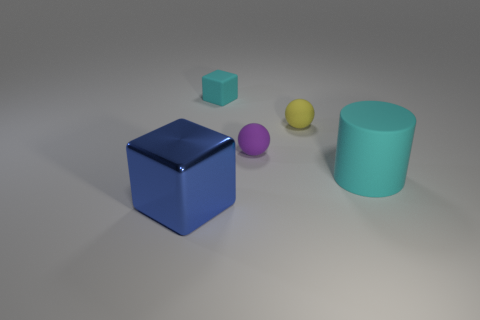How big is the cube that is to the right of the large cube?
Your answer should be very brief. Small. There is a cylinder that is the same size as the blue object; what is its color?
Provide a short and direct response. Cyan. Are there any small matte objects that have the same color as the big cylinder?
Offer a terse response. Yes. Are there fewer big metallic objects on the right side of the big matte object than purple things to the right of the cyan cube?
Give a very brief answer. Yes. What material is the object that is both in front of the purple thing and behind the large blue object?
Ensure brevity in your answer.  Rubber. Do the blue metal object and the cyan rubber thing on the left side of the large cyan object have the same shape?
Your response must be concise. Yes. How many other objects are there of the same size as the blue thing?
Your answer should be compact. 1. Are there more gray blocks than big rubber objects?
Make the answer very short. No. What number of large things are on the left side of the big matte cylinder and behind the large metal object?
Your answer should be compact. 0. What is the shape of the yellow object that is to the left of the cyan thing that is to the right of the cyan rubber object that is on the left side of the yellow rubber thing?
Your response must be concise. Sphere. 